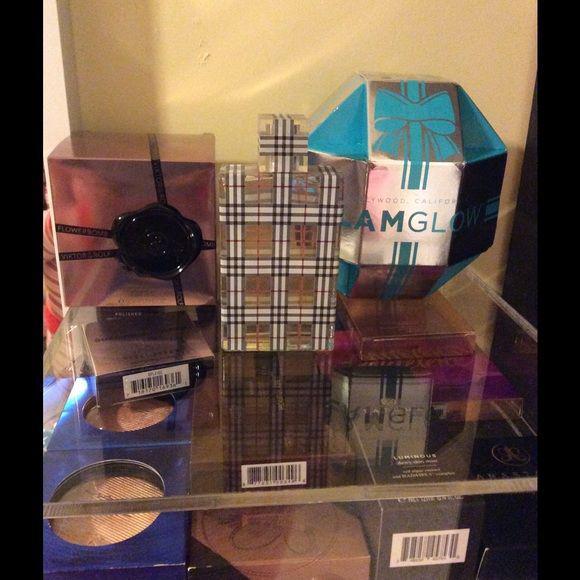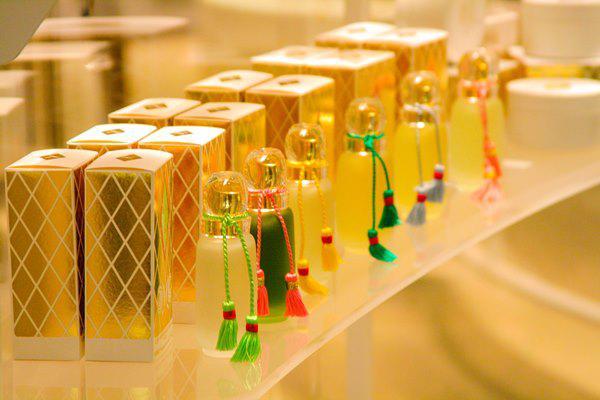The first image is the image on the left, the second image is the image on the right. Given the left and right images, does the statement "There are at least ten perfumes in the left image." hold true? Answer yes or no. No. The first image is the image on the left, the second image is the image on the right. Given the left and right images, does the statement "The left image shows one glass fragrance bottle in a reflective glass display, and the right image shows a white shelf that angles up to the right and holds fragrance bottles." hold true? Answer yes or no. Yes. 